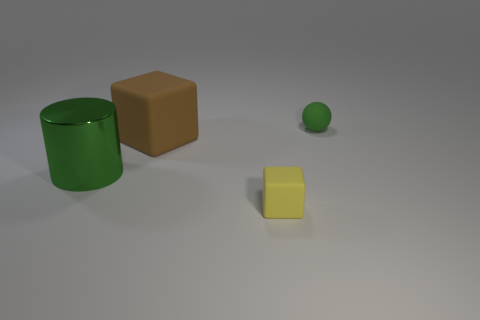Add 4 green shiny cylinders. How many objects exist? 8 Subtract all tiny green matte balls. Subtract all shiny cylinders. How many objects are left? 2 Add 4 yellow rubber objects. How many yellow rubber objects are left? 5 Add 2 big yellow shiny spheres. How many big yellow shiny spheres exist? 2 Subtract 1 green spheres. How many objects are left? 3 